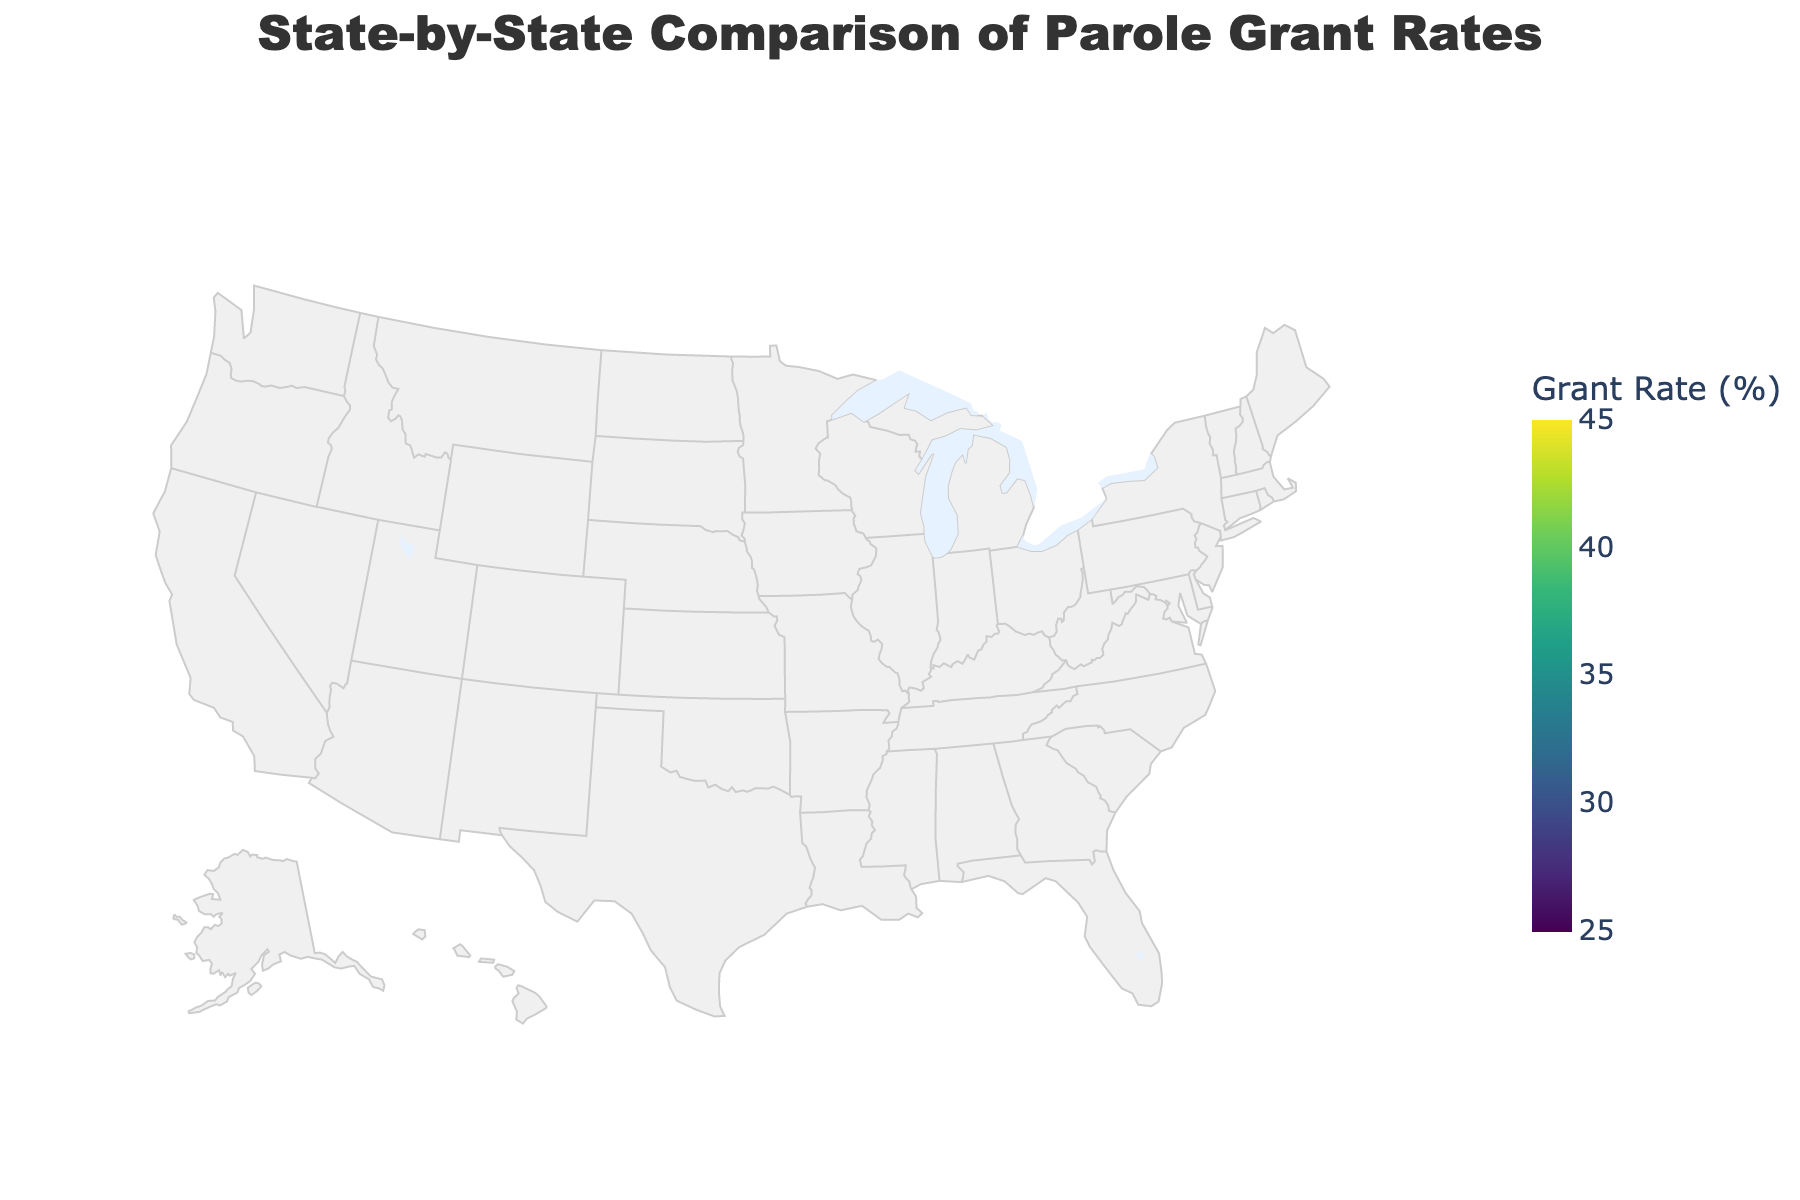What is the title of the figure? The title of the figure is displayed prominently at the top and provides an immediate understanding of what the figure represents.
Answer: State-by-State Comparison of Parole Grant Rates What state has the highest parole grant rate? By looking at the colors and checking the state-by-state legends, the state with the darkest shade corresponding to the highest rate should be identified.
Answer: New York Which state has the lowest parole grant rate? Similar to the previous question, the state with the lightest shade (or the least intense color) should indicate the lowest rate.
Answer: Louisiana What is the color scale used in the figure? The color scale used visually ranges from one color at one end of the data spectrum to another at the other end. The specific color scheme for this figure can be identified from the legend.
Answer: Viridis Which state has a parole grant rate closest to the middle of the provided range? The middle of the range provided is (45+25)/2 = 35. Checking the states with rates closest to this value from the color map should give the answer. From the data, Illinois with a rate of 35.6 is the closest.
Answer: Illinois How do the parole grant rates of California and Texas compare? By locating California and Texas on the map, compare the shades of colors for both states. California has a parole grant rate of 38.5% and Texas has a rate of 32.7%. California has a higher rate.
Answer: California > Texas Which states have parole grant rates above 40%? States with darker shades corresponding to the upper end of the color spectrum mentioned should be identified and listed. New York, Pennsylvania, Michigan, New Jersey, Connecticut, and Minnesota fit this category.
Answer: New York, Pennsylvania, Michigan, New Jersey, Connecticut, Minnesota What is the combined parole grant rate of Florida, Alabama, and Kentucky? By adding the rates of these three states: 28.9% (Florida) + 29.3% (Alabama) + 32.1% (Kentucky) = 90.3%.
Answer: 90.3% Which state has a higher parole grant rate, Pennsylvania or Washington? Compare the shades of Pennsylvania and Washington on the map. Pennsylvania has a rate of 41.8% and Washington has a rate of 36.4%.
Answer: Pennsylvania > Washington 